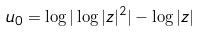Convert formula to latex. <formula><loc_0><loc_0><loc_500><loc_500>u _ { 0 } = \log | \log | z | ^ { 2 } | - \log | z |</formula> 